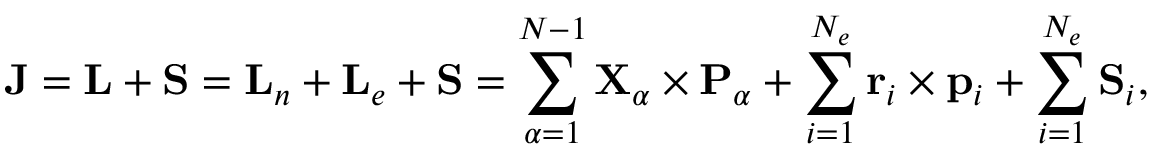Convert formula to latex. <formula><loc_0><loc_0><loc_500><loc_500>{ J } = { L } + { S } = { L } _ { n } + { L } _ { e } + { S } = \sum _ { \alpha = 1 } ^ { N - 1 } { X } _ { \alpha } \times { P } _ { \alpha } + \sum _ { i = 1 } ^ { N _ { e } } { r } _ { i } \times { p } _ { i } + \sum _ { i = 1 } ^ { N _ { e } } { S } _ { i } ,</formula> 